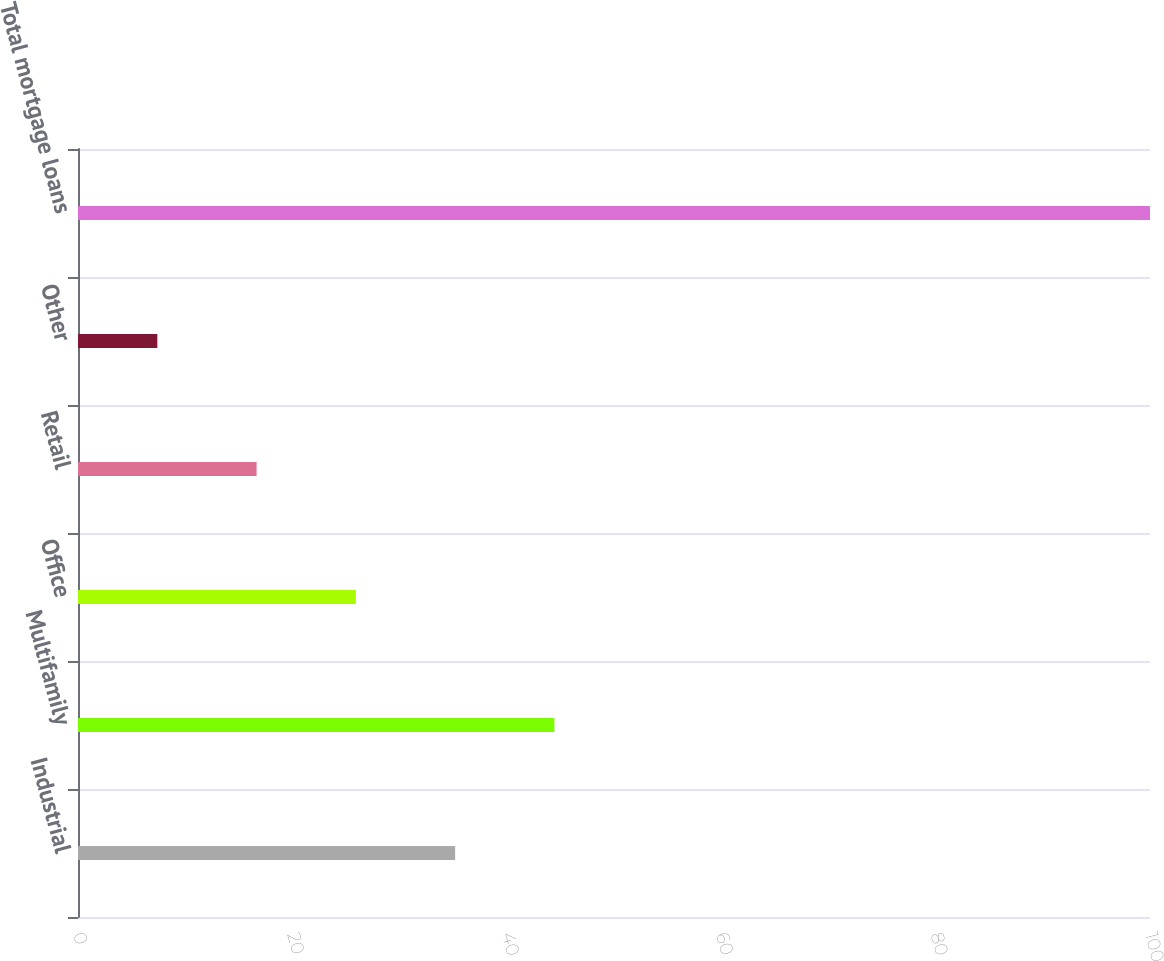<chart> <loc_0><loc_0><loc_500><loc_500><bar_chart><fcel>Industrial<fcel>Multifamily<fcel>Office<fcel>Retail<fcel>Other<fcel>Total mortgage loans<nl><fcel>35.18<fcel>44.44<fcel>25.92<fcel>16.66<fcel>7.4<fcel>100<nl></chart> 